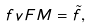<formula> <loc_0><loc_0><loc_500><loc_500>\ f v F M = \tilde { f } ,</formula> 